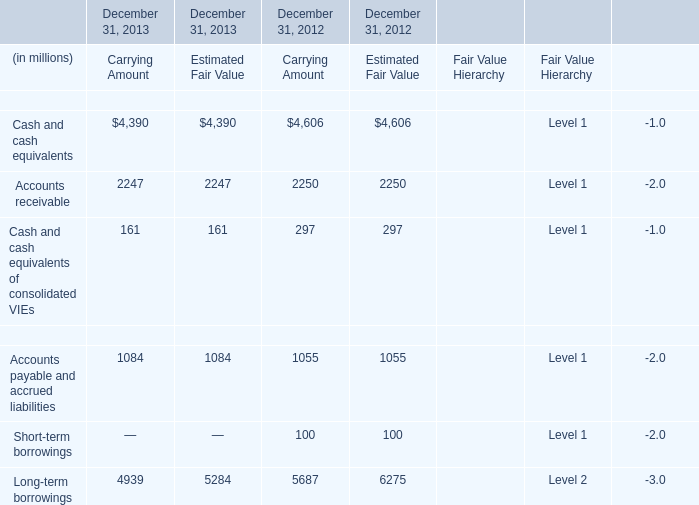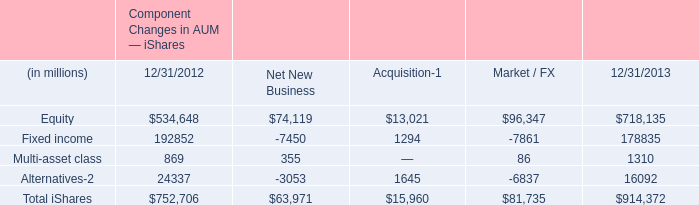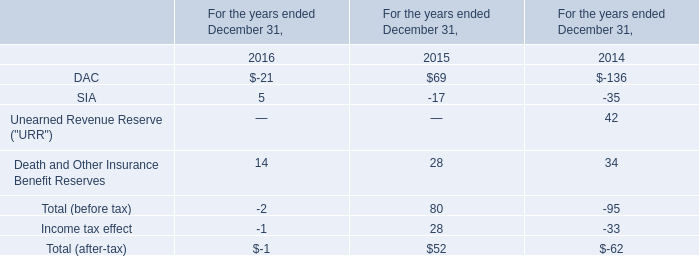what percent did the net inflows increase ishares aum? 
Computations: (41.4 / (655.6 - 41.4))
Answer: 0.0674. 